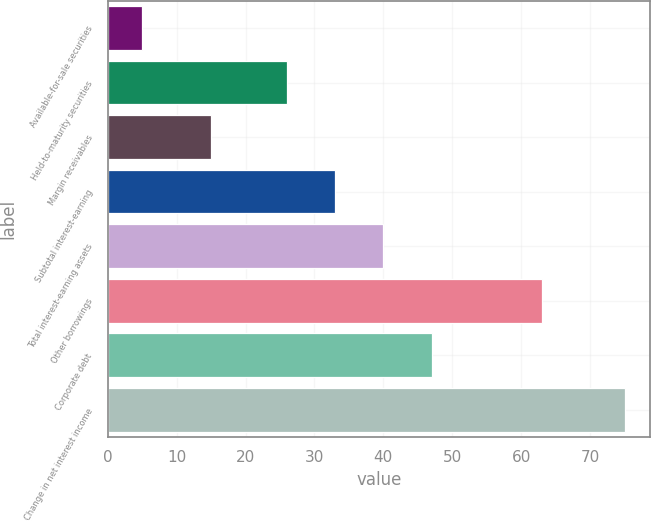<chart> <loc_0><loc_0><loc_500><loc_500><bar_chart><fcel>Available-for-sale securities<fcel>Held-to-maturity securities<fcel>Margin receivables<fcel>Subtotal interest-earning<fcel>Total interest-earning assets<fcel>Other borrowings<fcel>Corporate debt<fcel>Change in net interest income<nl><fcel>5<fcel>26<fcel>15<fcel>33<fcel>40<fcel>63<fcel>47<fcel>75<nl></chart> 